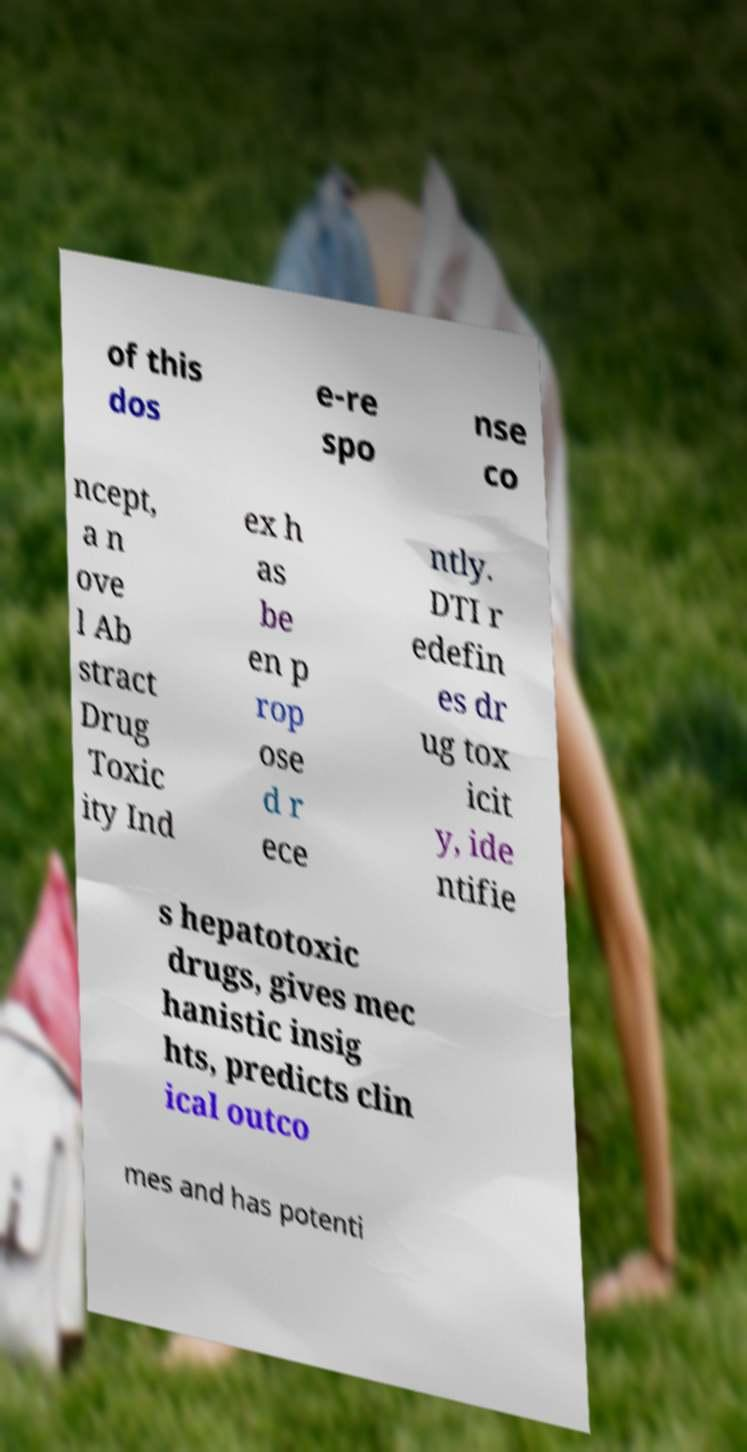Please identify and transcribe the text found in this image. of this dos e-re spo nse co ncept, a n ove l Ab stract Drug Toxic ity Ind ex h as be en p rop ose d r ece ntly. DTI r edefin es dr ug tox icit y, ide ntifie s hepatotoxic drugs, gives mec hanistic insig hts, predicts clin ical outco mes and has potenti 